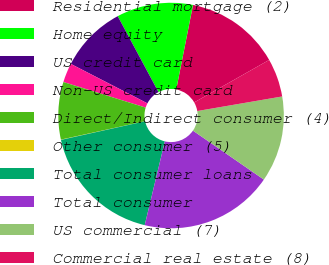Convert chart to OTSL. <chart><loc_0><loc_0><loc_500><loc_500><pie_chart><fcel>Residential mortgage (2)<fcel>Home equity<fcel>US credit card<fcel>Non-US credit card<fcel>Direct/Indirect consumer (4)<fcel>Other consumer (5)<fcel>Total consumer loans<fcel>Total consumer<fcel>US commercial (7)<fcel>Commercial real estate (8)<nl><fcel>13.68%<fcel>10.96%<fcel>9.59%<fcel>2.77%<fcel>8.23%<fcel>0.04%<fcel>17.78%<fcel>19.14%<fcel>12.32%<fcel>5.5%<nl></chart> 